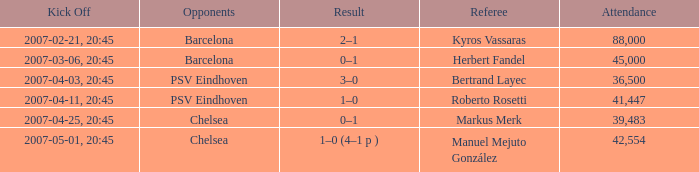What was the result of the match with a 2007-03-06, 20:45 start? 0–1. 